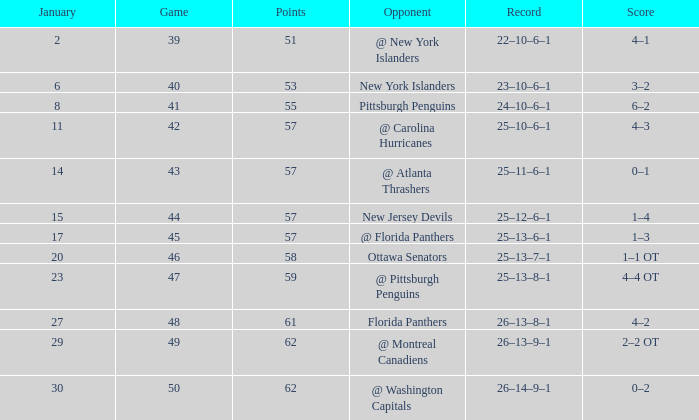What opponent has an average less than 62 and a january average less than 6 @ New York Islanders. 